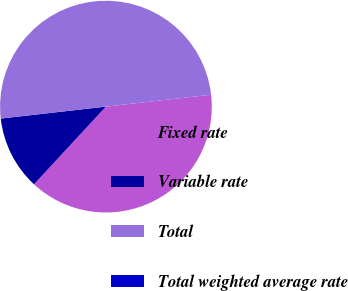<chart> <loc_0><loc_0><loc_500><loc_500><pie_chart><fcel>Fixed rate<fcel>Variable rate<fcel>Total<fcel>Total weighted average rate<nl><fcel>38.69%<fcel>11.31%<fcel>50.0%<fcel>0.0%<nl></chart> 